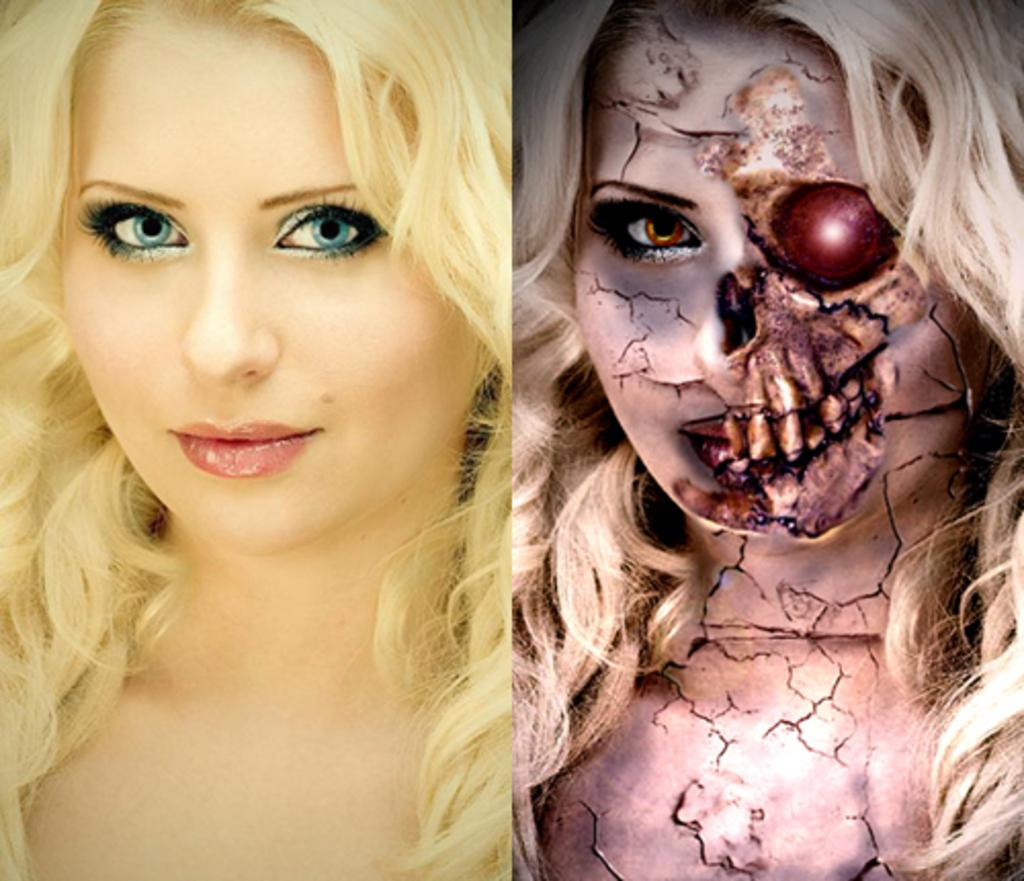What type of artwork is depicted in the image? There is a collage in the image. Can you describe the people in the collage? There is a person truncated towards the left of the image and an animated person truncated towards the right of the image. What type of crack is visible in the image? There is no crack visible in the image; it features a collage with two truncated figures. 